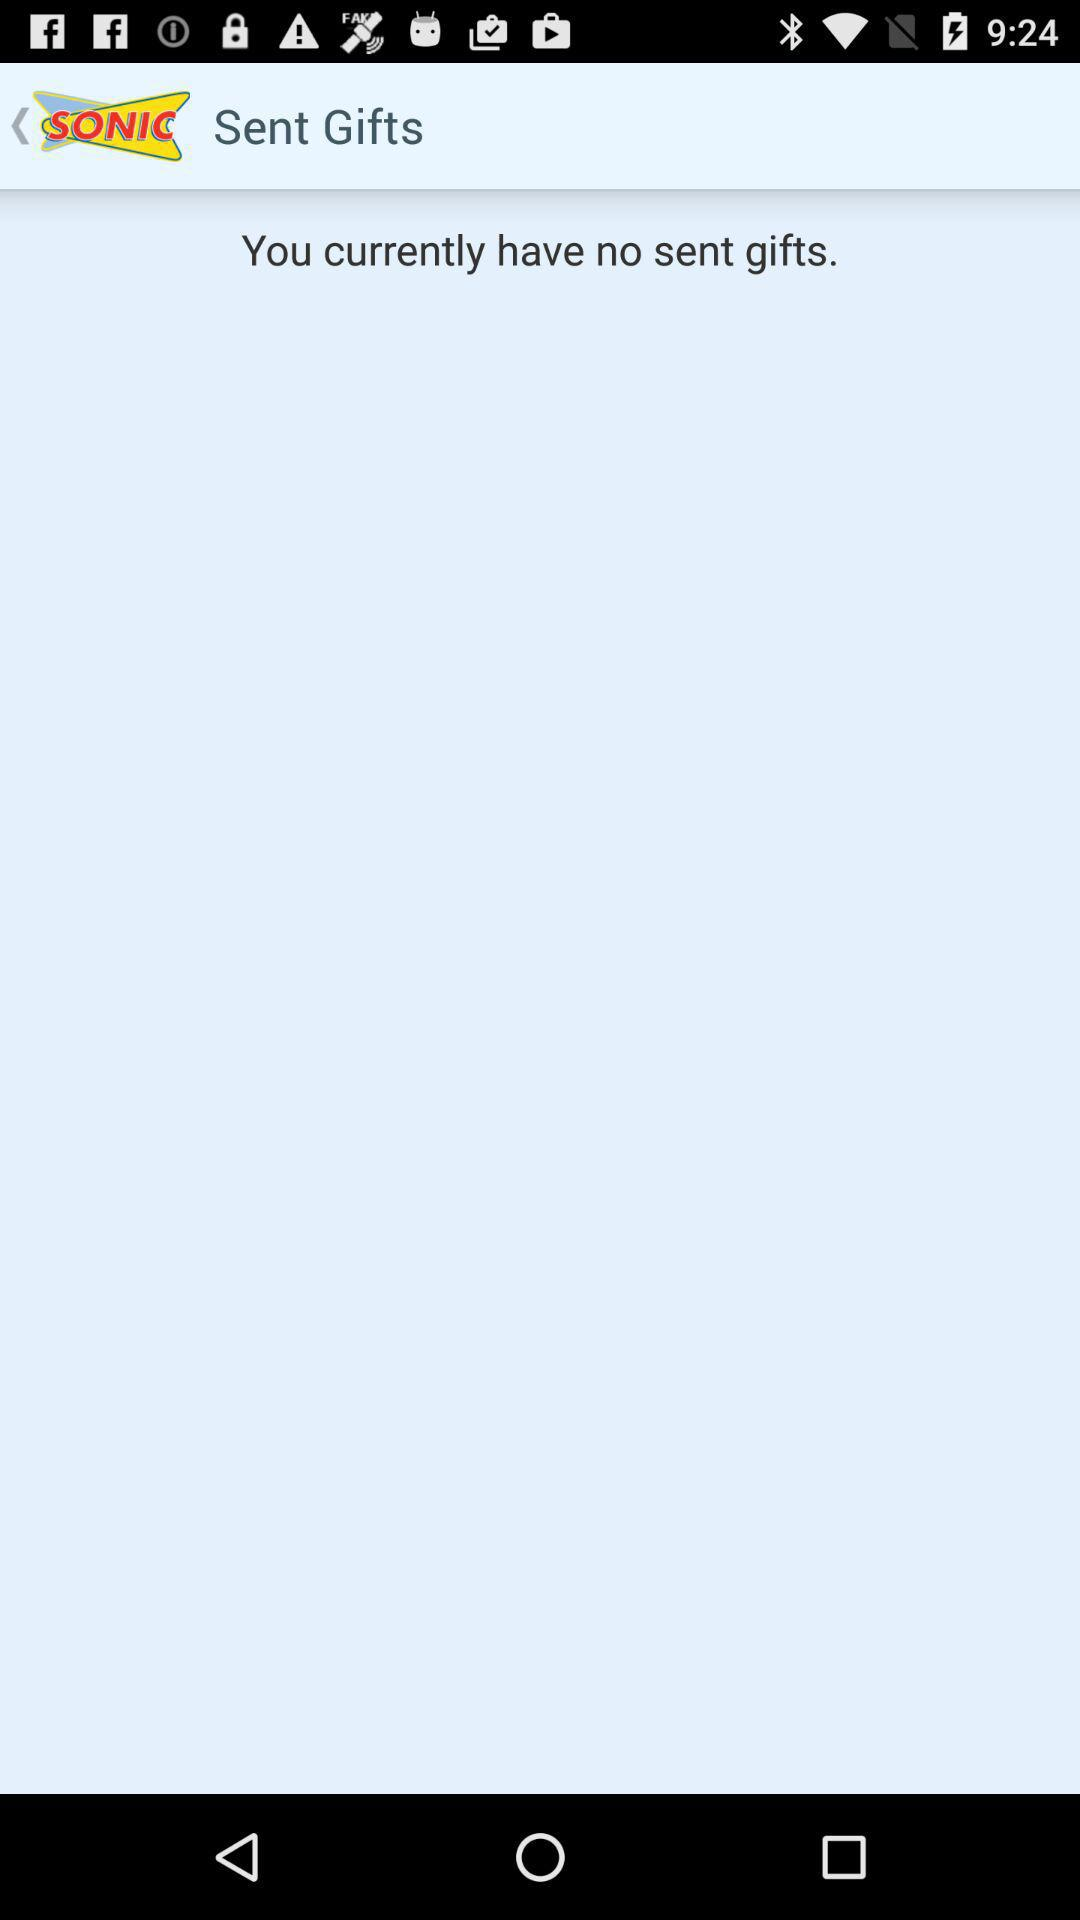What is the application name? The application name is "SONIC". 